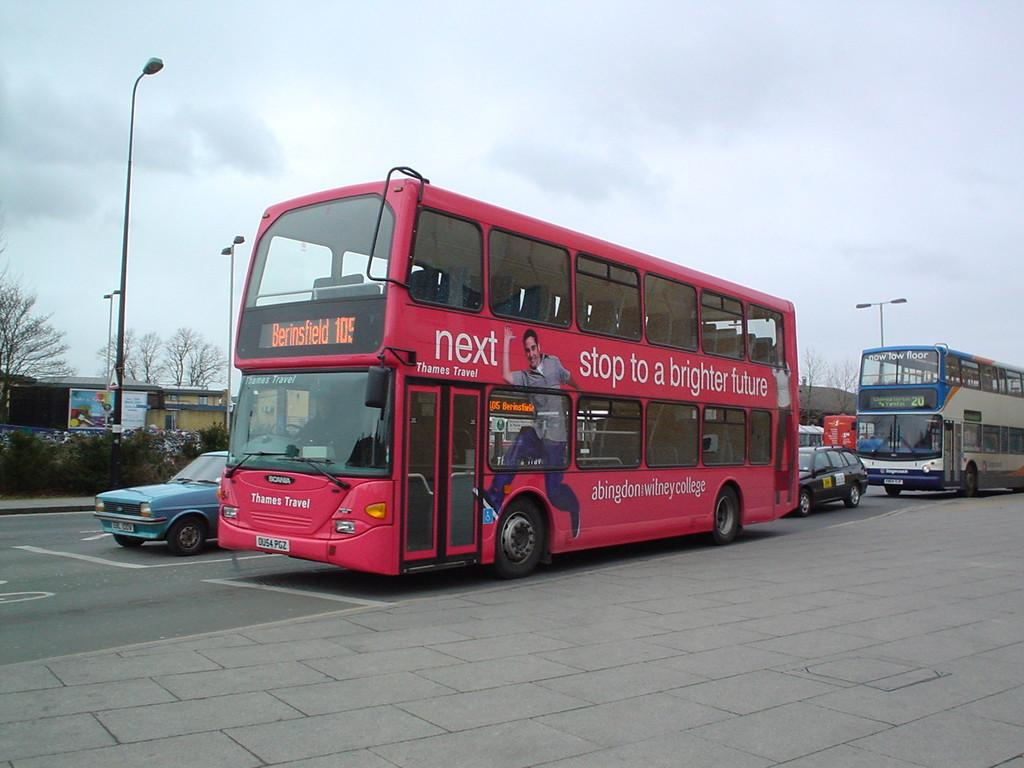What can be seen on the road in the image? There are vehicles parked on the road in the image. What type of natural elements are visible in the image? There are trees visible in the image. What type of man-made structures can be seen in the image? There are buildings in the image. What is visible at the top of the image? The sky is clear and visible at the top of the image. Can you see any children playing in the park in the image? There is no park or children playing visible in the image. What color is the tail of the dog in the image? There is no dog or tail present in the image. 